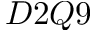Convert formula to latex. <formula><loc_0><loc_0><loc_500><loc_500>D 2 Q 9</formula> 